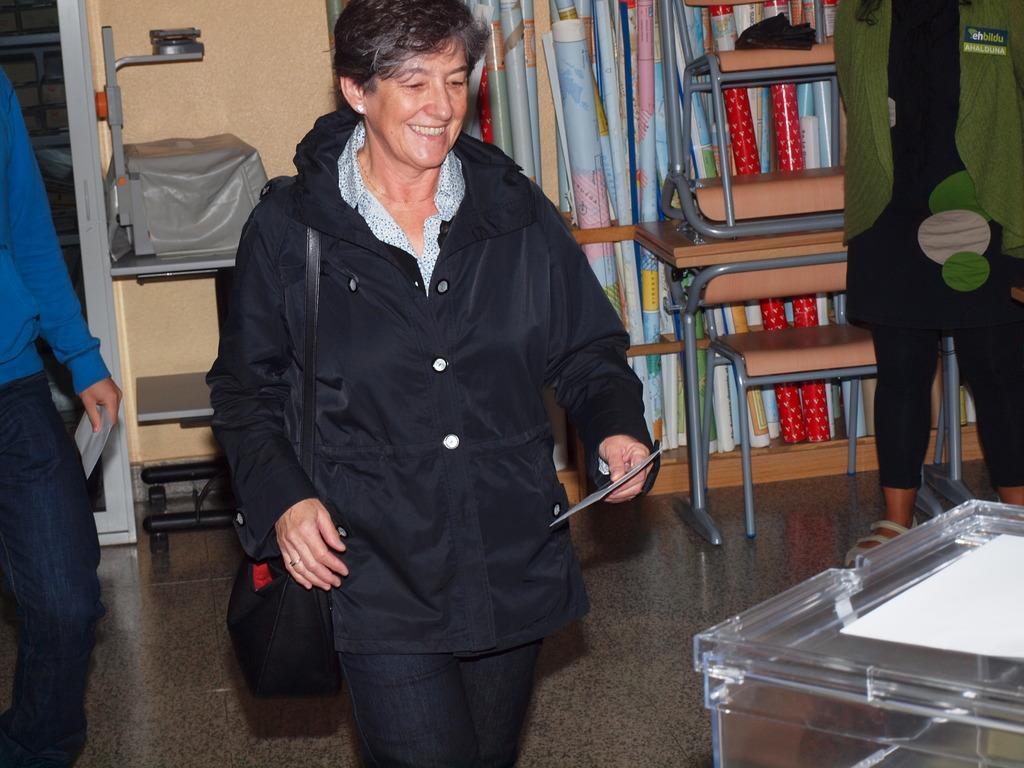Can you describe this image briefly? Here we can see a woman standing on the floor, and she is smiling, and at back here are the maps, and here is the wall, and her are the some objects. 